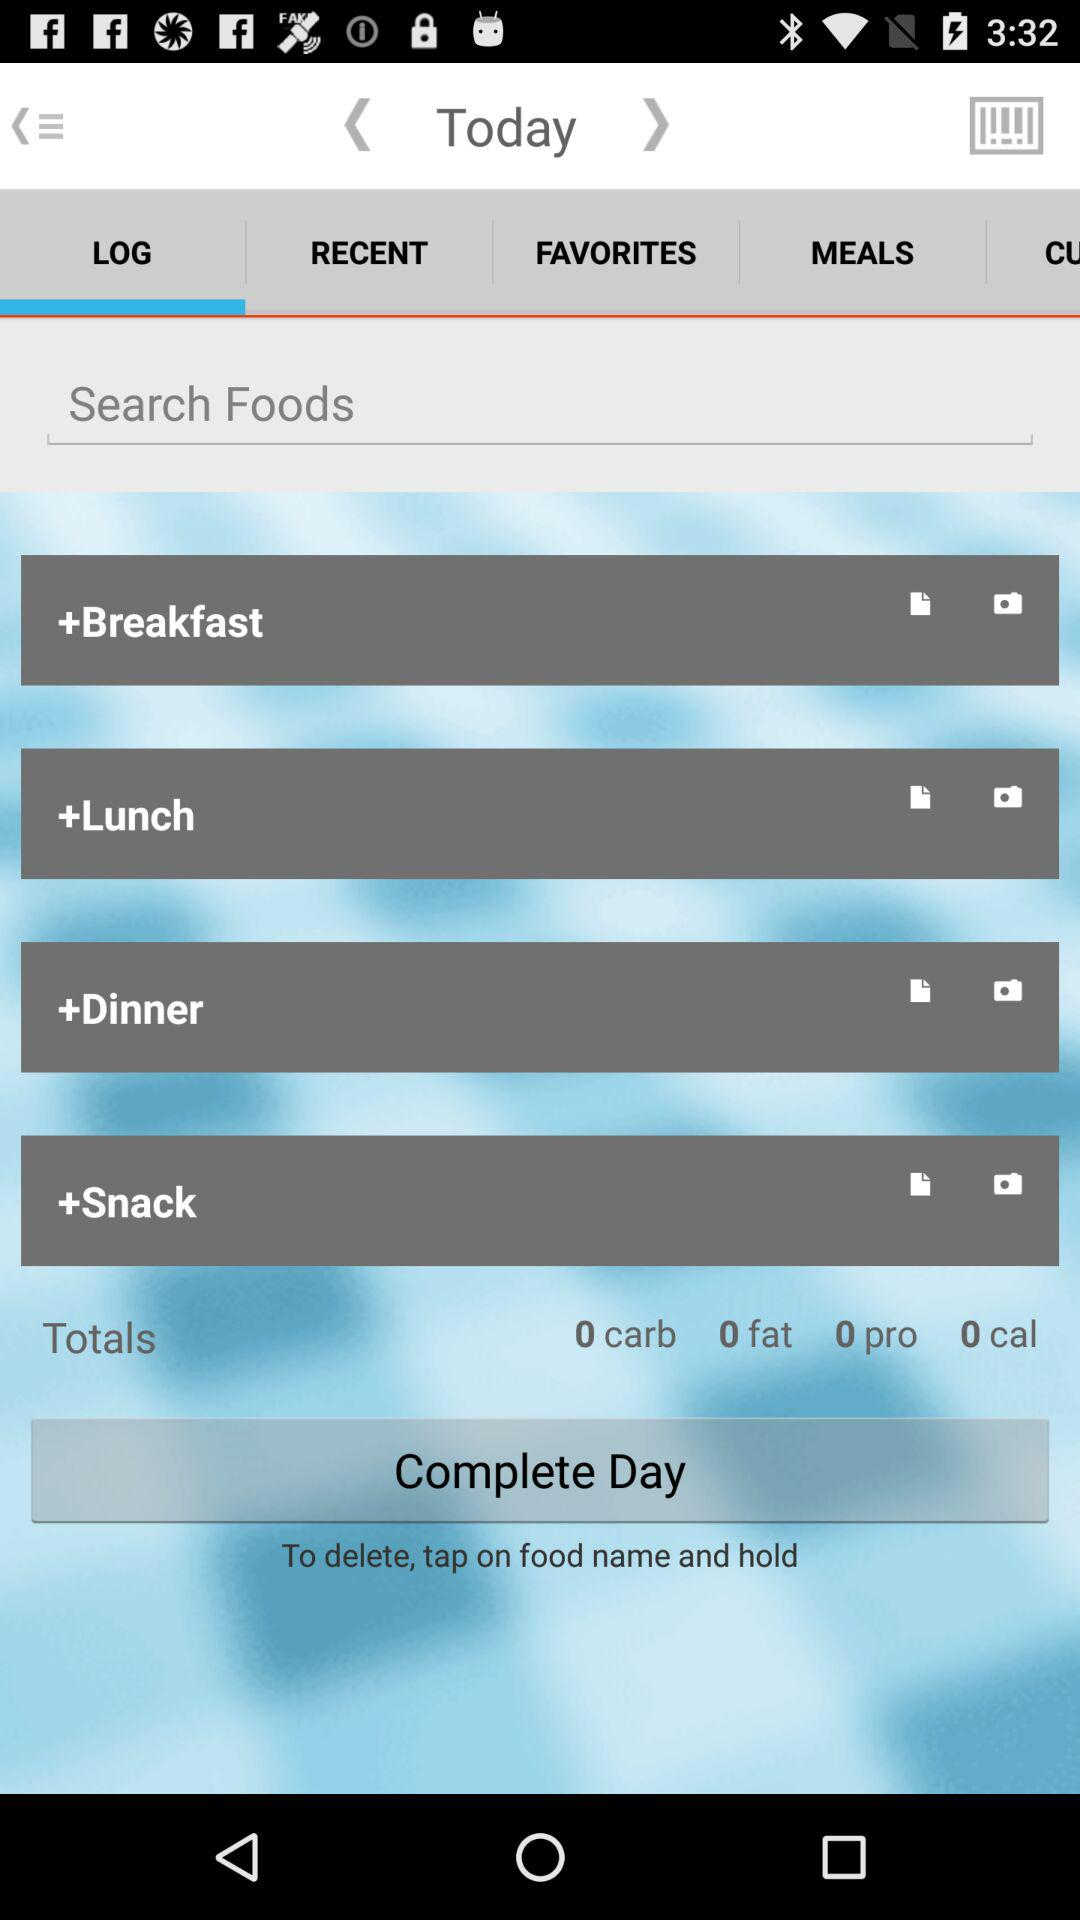What do we need to do to delete any food? To delete, you need to tap on the food name and hold. 